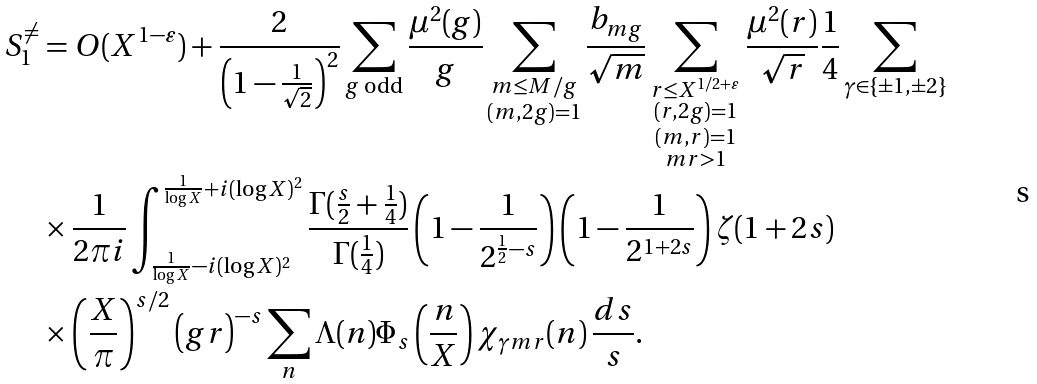<formula> <loc_0><loc_0><loc_500><loc_500>S _ { 1 } ^ { \neq } & = O ( X ^ { 1 - \varepsilon } ) + \frac { 2 } { \left ( 1 - \frac { 1 } { \sqrt { 2 } } \right ) ^ { 2 } } \sum _ { \substack { g \text { odd} } } \frac { \mu ^ { 2 } ( g ) } { g } \sum _ { \substack { m \leq M / g \\ ( m , 2 g ) = 1 } } \frac { b _ { m g } } { \sqrt { m } } \sum _ { \substack { r \leq X ^ { 1 / 2 + \varepsilon } \\ ( r , 2 g ) = 1 \\ ( m , r ) = 1 \\ m r > 1 } } \frac { \mu ^ { 2 } ( r ) } { \sqrt { r } } \frac { 1 } { 4 } \sum _ { \gamma \in \{ \pm 1 , \pm 2 \} } \\ & \times \frac { 1 } { 2 \pi i } \int _ { \frac { 1 } { \log X } - i ( \log X ) ^ { 2 } } ^ { \frac { 1 } { \log X } + i ( \log X ) ^ { 2 } } \frac { \Gamma ( \frac { s } { 2 } + \frac { 1 } { 4 } ) } { \Gamma ( \frac { 1 } { 4 } ) } \left ( 1 - \frac { 1 } { 2 ^ { \frac { 1 } { 2 } - s } } \right ) \left ( 1 - \frac { 1 } { 2 ^ { 1 + 2 s } } \right ) \zeta ( 1 + 2 s ) \\ & \times \left ( \frac { X } { \pi } \right ) ^ { s / 2 } \left ( g r \right ) ^ { - s } \sum _ { n } \Lambda ( n ) \Phi _ { s } \left ( \frac { n } { X } \right ) \chi _ { \gamma m r } ( n ) \, \frac { d s } { s } .</formula> 